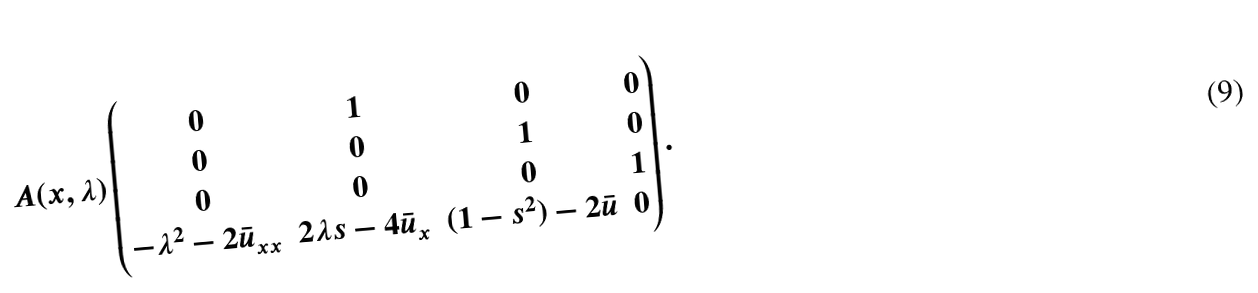<formula> <loc_0><loc_0><loc_500><loc_500>A ( x , \lambda ) \begin{pmatrix} 0 & 1 & 0 & 0 \\ 0 & 0 & 1 & 0 \\ 0 & 0 & 0 & 1 \\ - \lambda ^ { 2 } - 2 \bar { u } _ { x x } & 2 \lambda s - 4 \bar { u } _ { x } & ( 1 - s ^ { 2 } ) - 2 \bar { u } & 0 \end{pmatrix} .</formula> 